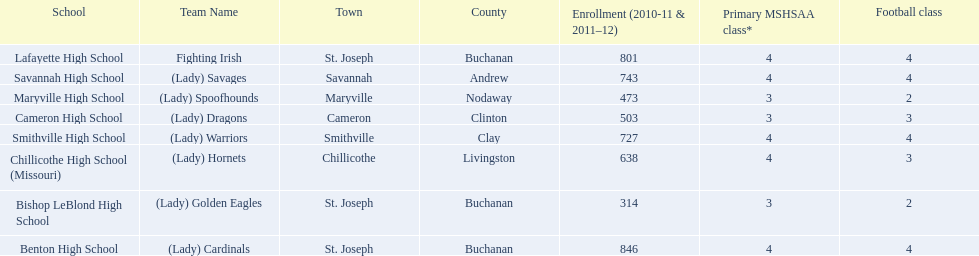How many are enrolled at each school? Benton High School, 846, Bishop LeBlond High School, 314, Cameron High School, 503, Chillicothe High School (Missouri), 638, Lafayette High School, 801, Maryville High School, 473, Savannah High School, 743, Smithville High School, 727. Which school has at only three football classes? Cameron High School, 3, Chillicothe High School (Missouri), 3. Which school has 638 enrolled and 3 football classes? Chillicothe High School (Missouri). 